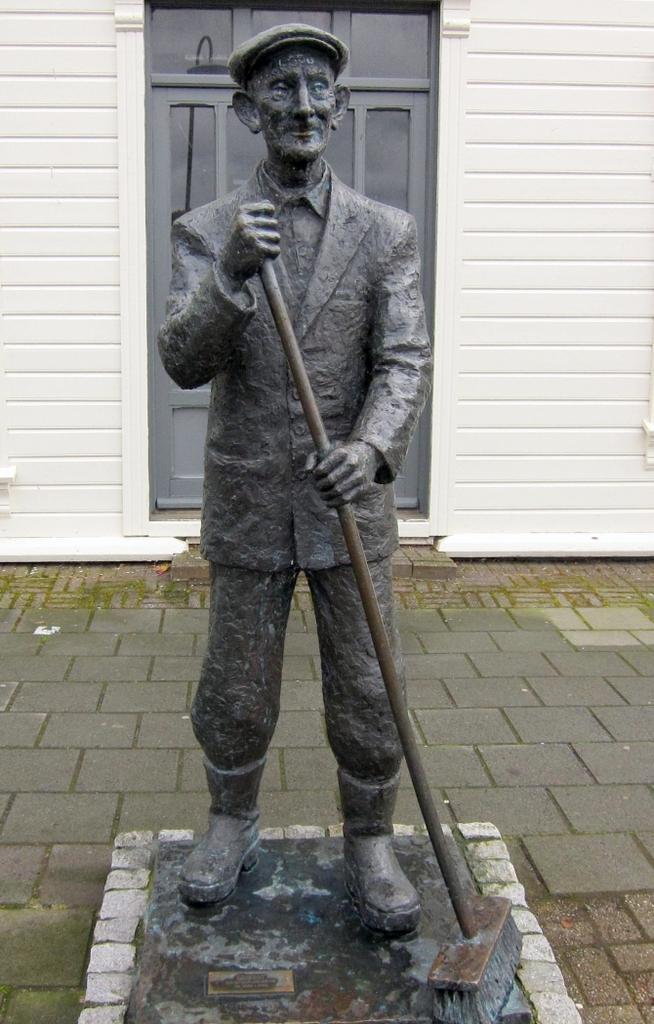Describe this image in one or two sentences. In this image we can see a statue of a person on a pedestal. And the person is holding something in the hand and he is wearing a cap. In the back there is a wall with a door. 